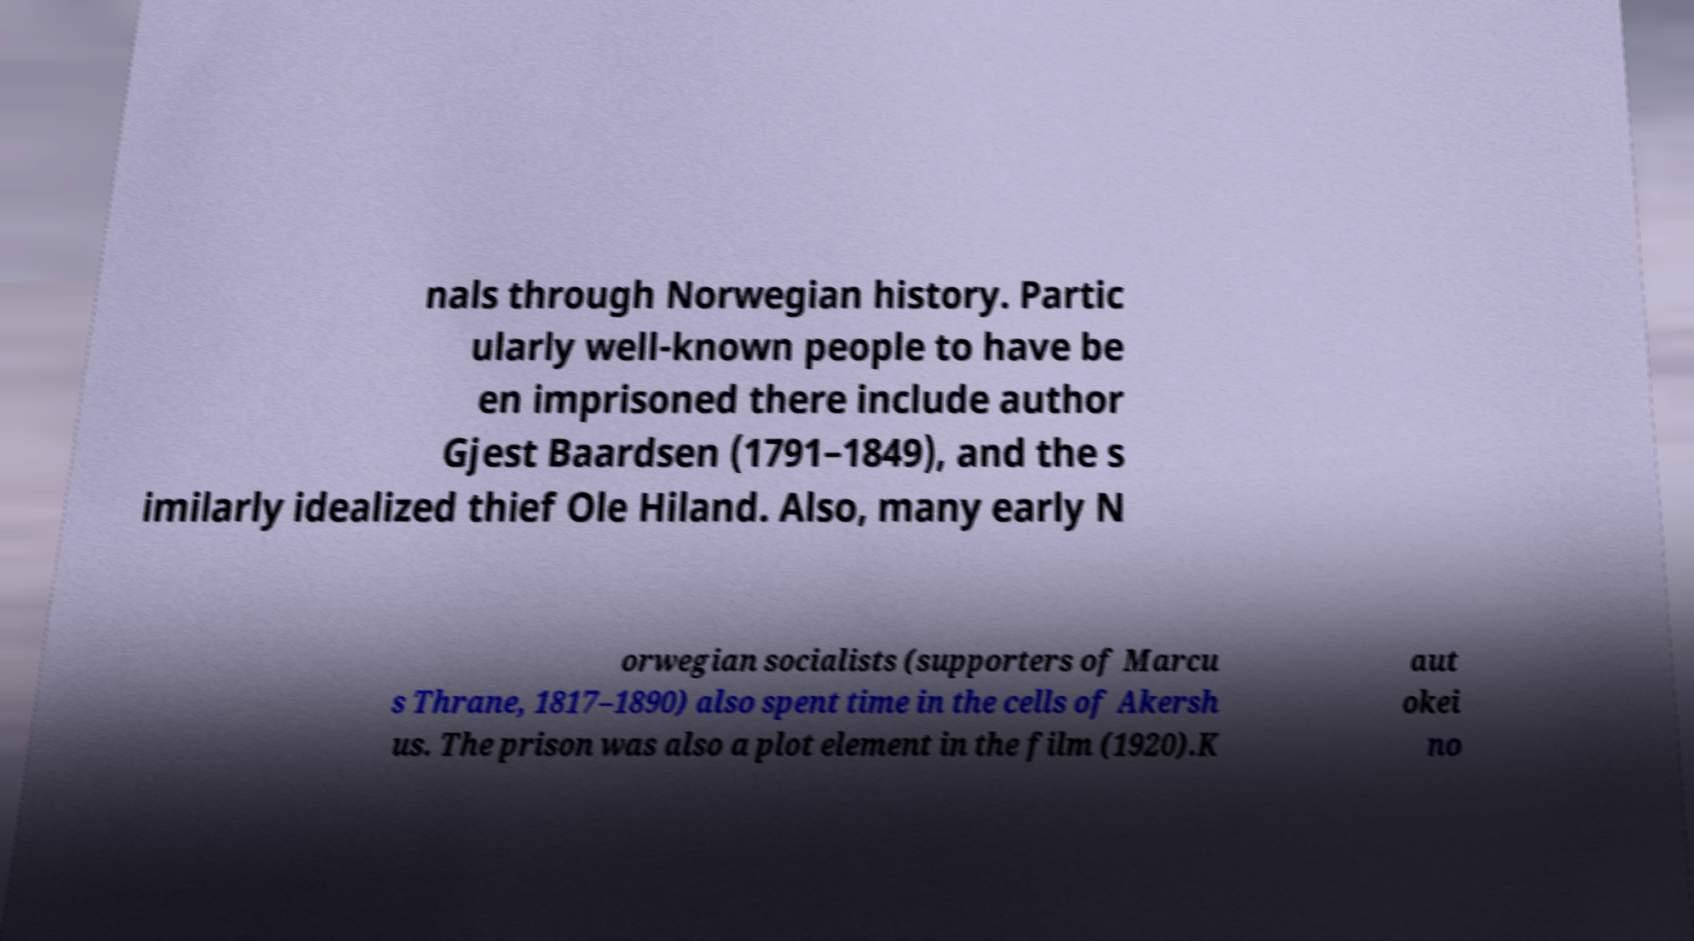There's text embedded in this image that I need extracted. Can you transcribe it verbatim? nals through Norwegian history. Partic ularly well-known people to have be en imprisoned there include author Gjest Baardsen (1791–1849), and the s imilarly idealized thief Ole Hiland. Also, many early N orwegian socialists (supporters of Marcu s Thrane, 1817–1890) also spent time in the cells of Akersh us. The prison was also a plot element in the film (1920).K aut okei no 